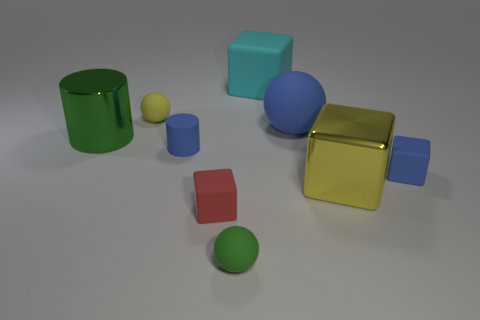Subtract 1 blocks. How many blocks are left? 3 Add 1 blue cylinders. How many objects exist? 10 Subtract all cylinders. How many objects are left? 7 Add 3 tiny red balls. How many tiny red balls exist? 3 Subtract 1 green balls. How many objects are left? 8 Subtract all small cyan matte things. Subtract all small blue blocks. How many objects are left? 8 Add 8 small yellow matte spheres. How many small yellow matte spheres are left? 9 